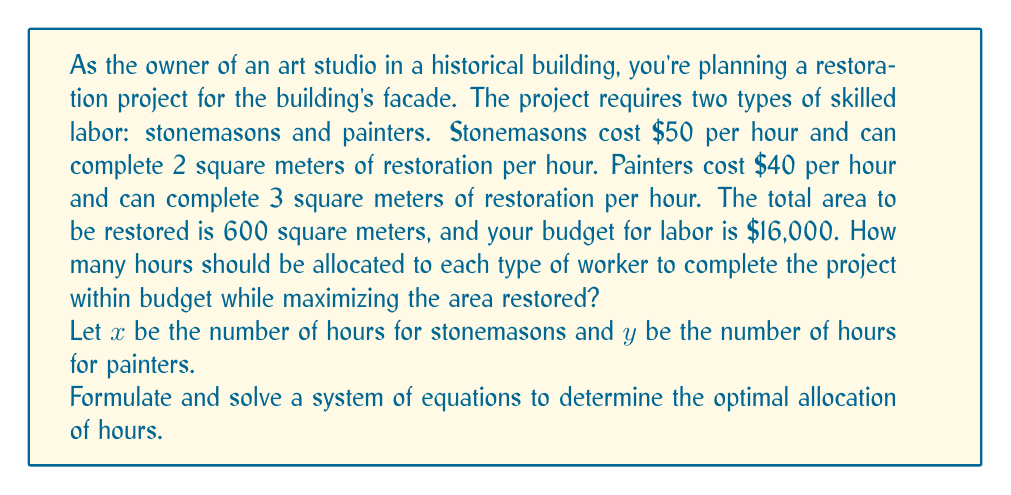Can you answer this question? Let's approach this step-by-step:

1) First, we need to set up our system of equations based on the given information:

   Equation 1 (Budget constraint): $50x + 40y = 16000$
   Equation 2 (Area constraint): $2x + 3y = 600$

2) We'll solve this system using substitution method:

3) From Equation 2, we can express $x$ in terms of $y$:
   $x = 300 - \frac{3}{2}y$

4) Substitute this into Equation 1:
   $50(300 - \frac{3}{2}y) + 40y = 16000$

5) Simplify:
   $15000 - 75y + 40y = 16000$
   $15000 - 35y = 16000$

6) Solve for $y$:
   $-35y = 1000$
   $y = -\frac{1000}{35} \approx 28.57$

7) Round $y$ to the nearest whole number: $y = 29$ hours for painters

8) Substitute back into the equation from step 3 to find $x$:
   $x = 300 - \frac{3}{2}(29) = 300 - 43.5 = 256.5$

9) Round $x$ to the nearest whole number: $x = 257$ hours for stonemasons

10) Verify the solution:
    Budget: $50(257) + 40(29) = 12850 + 1160 = 14010 < 16000$ (within budget)
    Area: $2(257) + 3(29) = 514 + 87 = 601$ sq meters (slightly over, but closest possible)
Answer: 257 hours for stonemasons, 29 hours for painters 